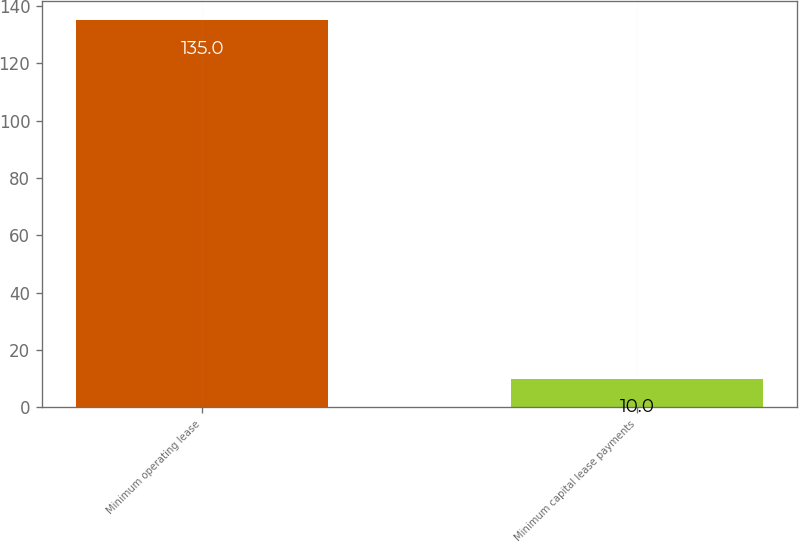<chart> <loc_0><loc_0><loc_500><loc_500><bar_chart><fcel>Minimum operating lease<fcel>Minimum capital lease payments<nl><fcel>135<fcel>10<nl></chart> 